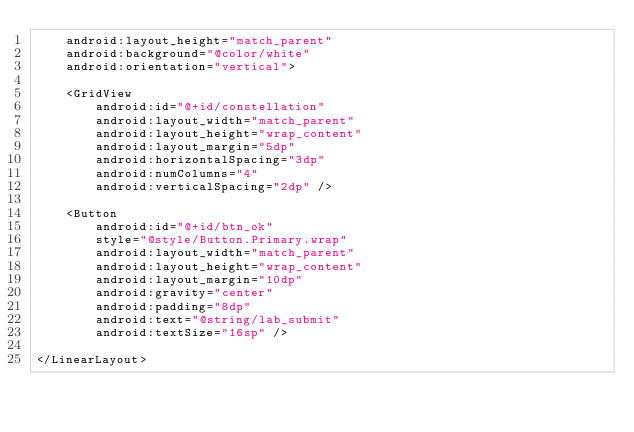<code> <loc_0><loc_0><loc_500><loc_500><_XML_>    android:layout_height="match_parent"
    android:background="@color/white"
    android:orientation="vertical">

    <GridView
        android:id="@+id/constellation"
        android:layout_width="match_parent"
        android:layout_height="wrap_content"
        android:layout_margin="5dp"
        android:horizontalSpacing="3dp"
        android:numColumns="4"
        android:verticalSpacing="2dp" />

    <Button
        android:id="@+id/btn_ok"
        style="@style/Button.Primary.wrap"
        android:layout_width="match_parent"
        android:layout_height="wrap_content"
        android:layout_margin="10dp"
        android:gravity="center"
        android:padding="8dp"
        android:text="@string/lab_submit"
        android:textSize="16sp" />

</LinearLayout>
</code> 